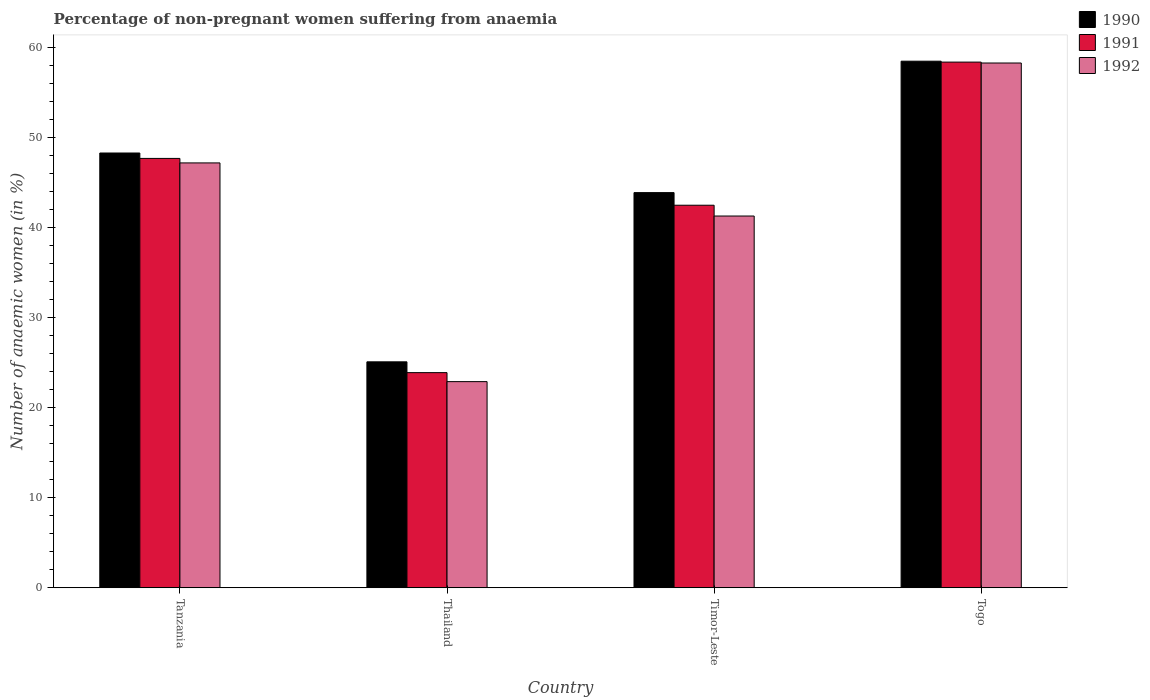How many different coloured bars are there?
Your response must be concise. 3. Are the number of bars on each tick of the X-axis equal?
Keep it short and to the point. Yes. What is the label of the 4th group of bars from the left?
Your answer should be compact. Togo. What is the percentage of non-pregnant women suffering from anaemia in 1990 in Tanzania?
Give a very brief answer. 48.3. Across all countries, what is the maximum percentage of non-pregnant women suffering from anaemia in 1991?
Offer a terse response. 58.4. Across all countries, what is the minimum percentage of non-pregnant women suffering from anaemia in 1991?
Your answer should be compact. 23.9. In which country was the percentage of non-pregnant women suffering from anaemia in 1992 maximum?
Make the answer very short. Togo. In which country was the percentage of non-pregnant women suffering from anaemia in 1991 minimum?
Provide a short and direct response. Thailand. What is the total percentage of non-pregnant women suffering from anaemia in 1990 in the graph?
Provide a short and direct response. 175.8. What is the difference between the percentage of non-pregnant women suffering from anaemia in 1990 in Tanzania and that in Togo?
Your answer should be compact. -10.2. What is the difference between the percentage of non-pregnant women suffering from anaemia in 1990 in Timor-Leste and the percentage of non-pregnant women suffering from anaemia in 1991 in Thailand?
Keep it short and to the point. 20. What is the average percentage of non-pregnant women suffering from anaemia in 1990 per country?
Offer a terse response. 43.95. What is the difference between the percentage of non-pregnant women suffering from anaemia of/in 1992 and percentage of non-pregnant women suffering from anaemia of/in 1990 in Tanzania?
Offer a very short reply. -1.1. What is the ratio of the percentage of non-pregnant women suffering from anaemia in 1991 in Tanzania to that in Togo?
Ensure brevity in your answer.  0.82. Is the percentage of non-pregnant women suffering from anaemia in 1991 in Timor-Leste less than that in Togo?
Offer a terse response. Yes. Is the difference between the percentage of non-pregnant women suffering from anaemia in 1992 in Thailand and Timor-Leste greater than the difference between the percentage of non-pregnant women suffering from anaemia in 1990 in Thailand and Timor-Leste?
Offer a terse response. Yes. What is the difference between the highest and the second highest percentage of non-pregnant women suffering from anaemia in 1991?
Your answer should be very brief. 15.9. What is the difference between the highest and the lowest percentage of non-pregnant women suffering from anaemia in 1991?
Offer a terse response. 34.5. Is the sum of the percentage of non-pregnant women suffering from anaemia in 1990 in Tanzania and Thailand greater than the maximum percentage of non-pregnant women suffering from anaemia in 1991 across all countries?
Offer a very short reply. Yes. What does the 2nd bar from the left in Tanzania represents?
Your response must be concise. 1991. How many bars are there?
Provide a succinct answer. 12. Are all the bars in the graph horizontal?
Your answer should be very brief. No. How many countries are there in the graph?
Your response must be concise. 4. How many legend labels are there?
Offer a very short reply. 3. How are the legend labels stacked?
Offer a terse response. Vertical. What is the title of the graph?
Your response must be concise. Percentage of non-pregnant women suffering from anaemia. Does "2004" appear as one of the legend labels in the graph?
Your answer should be very brief. No. What is the label or title of the Y-axis?
Offer a terse response. Number of anaemic women (in %). What is the Number of anaemic women (in %) of 1990 in Tanzania?
Provide a short and direct response. 48.3. What is the Number of anaemic women (in %) in 1991 in Tanzania?
Provide a succinct answer. 47.7. What is the Number of anaemic women (in %) in 1992 in Tanzania?
Offer a very short reply. 47.2. What is the Number of anaemic women (in %) of 1990 in Thailand?
Your answer should be very brief. 25.1. What is the Number of anaemic women (in %) in 1991 in Thailand?
Your answer should be very brief. 23.9. What is the Number of anaemic women (in %) in 1992 in Thailand?
Offer a terse response. 22.9. What is the Number of anaemic women (in %) of 1990 in Timor-Leste?
Give a very brief answer. 43.9. What is the Number of anaemic women (in %) in 1991 in Timor-Leste?
Ensure brevity in your answer.  42.5. What is the Number of anaemic women (in %) in 1992 in Timor-Leste?
Keep it short and to the point. 41.3. What is the Number of anaemic women (in %) of 1990 in Togo?
Your response must be concise. 58.5. What is the Number of anaemic women (in %) in 1991 in Togo?
Your answer should be compact. 58.4. What is the Number of anaemic women (in %) of 1992 in Togo?
Offer a very short reply. 58.3. Across all countries, what is the maximum Number of anaemic women (in %) in 1990?
Keep it short and to the point. 58.5. Across all countries, what is the maximum Number of anaemic women (in %) of 1991?
Your answer should be very brief. 58.4. Across all countries, what is the maximum Number of anaemic women (in %) in 1992?
Offer a terse response. 58.3. Across all countries, what is the minimum Number of anaemic women (in %) in 1990?
Make the answer very short. 25.1. Across all countries, what is the minimum Number of anaemic women (in %) in 1991?
Offer a very short reply. 23.9. Across all countries, what is the minimum Number of anaemic women (in %) in 1992?
Ensure brevity in your answer.  22.9. What is the total Number of anaemic women (in %) of 1990 in the graph?
Ensure brevity in your answer.  175.8. What is the total Number of anaemic women (in %) in 1991 in the graph?
Your answer should be very brief. 172.5. What is the total Number of anaemic women (in %) of 1992 in the graph?
Offer a very short reply. 169.7. What is the difference between the Number of anaemic women (in %) in 1990 in Tanzania and that in Thailand?
Offer a very short reply. 23.2. What is the difference between the Number of anaemic women (in %) in 1991 in Tanzania and that in Thailand?
Provide a succinct answer. 23.8. What is the difference between the Number of anaemic women (in %) of 1992 in Tanzania and that in Thailand?
Ensure brevity in your answer.  24.3. What is the difference between the Number of anaemic women (in %) in 1990 in Tanzania and that in Timor-Leste?
Keep it short and to the point. 4.4. What is the difference between the Number of anaemic women (in %) of 1991 in Tanzania and that in Timor-Leste?
Keep it short and to the point. 5.2. What is the difference between the Number of anaemic women (in %) of 1991 in Tanzania and that in Togo?
Keep it short and to the point. -10.7. What is the difference between the Number of anaemic women (in %) of 1992 in Tanzania and that in Togo?
Ensure brevity in your answer.  -11.1. What is the difference between the Number of anaemic women (in %) of 1990 in Thailand and that in Timor-Leste?
Provide a short and direct response. -18.8. What is the difference between the Number of anaemic women (in %) of 1991 in Thailand and that in Timor-Leste?
Provide a short and direct response. -18.6. What is the difference between the Number of anaemic women (in %) of 1992 in Thailand and that in Timor-Leste?
Your response must be concise. -18.4. What is the difference between the Number of anaemic women (in %) of 1990 in Thailand and that in Togo?
Offer a very short reply. -33.4. What is the difference between the Number of anaemic women (in %) of 1991 in Thailand and that in Togo?
Your answer should be compact. -34.5. What is the difference between the Number of anaemic women (in %) in 1992 in Thailand and that in Togo?
Keep it short and to the point. -35.4. What is the difference between the Number of anaemic women (in %) in 1990 in Timor-Leste and that in Togo?
Give a very brief answer. -14.6. What is the difference between the Number of anaemic women (in %) in 1991 in Timor-Leste and that in Togo?
Provide a short and direct response. -15.9. What is the difference between the Number of anaemic women (in %) of 1992 in Timor-Leste and that in Togo?
Your answer should be very brief. -17. What is the difference between the Number of anaemic women (in %) in 1990 in Tanzania and the Number of anaemic women (in %) in 1991 in Thailand?
Keep it short and to the point. 24.4. What is the difference between the Number of anaemic women (in %) of 1990 in Tanzania and the Number of anaemic women (in %) of 1992 in Thailand?
Provide a succinct answer. 25.4. What is the difference between the Number of anaemic women (in %) in 1991 in Tanzania and the Number of anaemic women (in %) in 1992 in Thailand?
Your answer should be very brief. 24.8. What is the difference between the Number of anaemic women (in %) in 1990 in Tanzania and the Number of anaemic women (in %) in 1992 in Timor-Leste?
Your response must be concise. 7. What is the difference between the Number of anaemic women (in %) in 1991 in Tanzania and the Number of anaemic women (in %) in 1992 in Togo?
Offer a very short reply. -10.6. What is the difference between the Number of anaemic women (in %) of 1990 in Thailand and the Number of anaemic women (in %) of 1991 in Timor-Leste?
Your response must be concise. -17.4. What is the difference between the Number of anaemic women (in %) in 1990 in Thailand and the Number of anaemic women (in %) in 1992 in Timor-Leste?
Make the answer very short. -16.2. What is the difference between the Number of anaemic women (in %) in 1991 in Thailand and the Number of anaemic women (in %) in 1992 in Timor-Leste?
Make the answer very short. -17.4. What is the difference between the Number of anaemic women (in %) of 1990 in Thailand and the Number of anaemic women (in %) of 1991 in Togo?
Provide a short and direct response. -33.3. What is the difference between the Number of anaemic women (in %) of 1990 in Thailand and the Number of anaemic women (in %) of 1992 in Togo?
Make the answer very short. -33.2. What is the difference between the Number of anaemic women (in %) in 1991 in Thailand and the Number of anaemic women (in %) in 1992 in Togo?
Offer a terse response. -34.4. What is the difference between the Number of anaemic women (in %) of 1990 in Timor-Leste and the Number of anaemic women (in %) of 1992 in Togo?
Keep it short and to the point. -14.4. What is the difference between the Number of anaemic women (in %) of 1991 in Timor-Leste and the Number of anaemic women (in %) of 1992 in Togo?
Give a very brief answer. -15.8. What is the average Number of anaemic women (in %) in 1990 per country?
Your answer should be very brief. 43.95. What is the average Number of anaemic women (in %) in 1991 per country?
Keep it short and to the point. 43.12. What is the average Number of anaemic women (in %) in 1992 per country?
Provide a short and direct response. 42.42. What is the difference between the Number of anaemic women (in %) in 1990 and Number of anaemic women (in %) in 1991 in Tanzania?
Your response must be concise. 0.6. What is the difference between the Number of anaemic women (in %) in 1990 and Number of anaemic women (in %) in 1992 in Tanzania?
Keep it short and to the point. 1.1. What is the difference between the Number of anaemic women (in %) in 1990 and Number of anaemic women (in %) in 1991 in Thailand?
Ensure brevity in your answer.  1.2. What is the difference between the Number of anaemic women (in %) in 1991 and Number of anaemic women (in %) in 1992 in Thailand?
Make the answer very short. 1. What is the difference between the Number of anaemic women (in %) of 1990 and Number of anaemic women (in %) of 1992 in Timor-Leste?
Your answer should be compact. 2.6. What is the difference between the Number of anaemic women (in %) of 1990 and Number of anaemic women (in %) of 1992 in Togo?
Provide a succinct answer. 0.2. What is the difference between the Number of anaemic women (in %) in 1991 and Number of anaemic women (in %) in 1992 in Togo?
Offer a terse response. 0.1. What is the ratio of the Number of anaemic women (in %) of 1990 in Tanzania to that in Thailand?
Your answer should be compact. 1.92. What is the ratio of the Number of anaemic women (in %) of 1991 in Tanzania to that in Thailand?
Make the answer very short. 2. What is the ratio of the Number of anaemic women (in %) of 1992 in Tanzania to that in Thailand?
Provide a short and direct response. 2.06. What is the ratio of the Number of anaemic women (in %) of 1990 in Tanzania to that in Timor-Leste?
Offer a very short reply. 1.1. What is the ratio of the Number of anaemic women (in %) in 1991 in Tanzania to that in Timor-Leste?
Make the answer very short. 1.12. What is the ratio of the Number of anaemic women (in %) of 1992 in Tanzania to that in Timor-Leste?
Ensure brevity in your answer.  1.14. What is the ratio of the Number of anaemic women (in %) in 1990 in Tanzania to that in Togo?
Provide a short and direct response. 0.83. What is the ratio of the Number of anaemic women (in %) in 1991 in Tanzania to that in Togo?
Provide a short and direct response. 0.82. What is the ratio of the Number of anaemic women (in %) in 1992 in Tanzania to that in Togo?
Make the answer very short. 0.81. What is the ratio of the Number of anaemic women (in %) in 1990 in Thailand to that in Timor-Leste?
Give a very brief answer. 0.57. What is the ratio of the Number of anaemic women (in %) in 1991 in Thailand to that in Timor-Leste?
Make the answer very short. 0.56. What is the ratio of the Number of anaemic women (in %) in 1992 in Thailand to that in Timor-Leste?
Provide a succinct answer. 0.55. What is the ratio of the Number of anaemic women (in %) of 1990 in Thailand to that in Togo?
Provide a succinct answer. 0.43. What is the ratio of the Number of anaemic women (in %) of 1991 in Thailand to that in Togo?
Keep it short and to the point. 0.41. What is the ratio of the Number of anaemic women (in %) of 1992 in Thailand to that in Togo?
Your answer should be compact. 0.39. What is the ratio of the Number of anaemic women (in %) of 1990 in Timor-Leste to that in Togo?
Provide a short and direct response. 0.75. What is the ratio of the Number of anaemic women (in %) in 1991 in Timor-Leste to that in Togo?
Give a very brief answer. 0.73. What is the ratio of the Number of anaemic women (in %) in 1992 in Timor-Leste to that in Togo?
Provide a short and direct response. 0.71. What is the difference between the highest and the second highest Number of anaemic women (in %) in 1990?
Offer a terse response. 10.2. What is the difference between the highest and the second highest Number of anaemic women (in %) of 1991?
Provide a succinct answer. 10.7. What is the difference between the highest and the second highest Number of anaemic women (in %) of 1992?
Ensure brevity in your answer.  11.1. What is the difference between the highest and the lowest Number of anaemic women (in %) in 1990?
Your response must be concise. 33.4. What is the difference between the highest and the lowest Number of anaemic women (in %) in 1991?
Make the answer very short. 34.5. What is the difference between the highest and the lowest Number of anaemic women (in %) of 1992?
Provide a succinct answer. 35.4. 